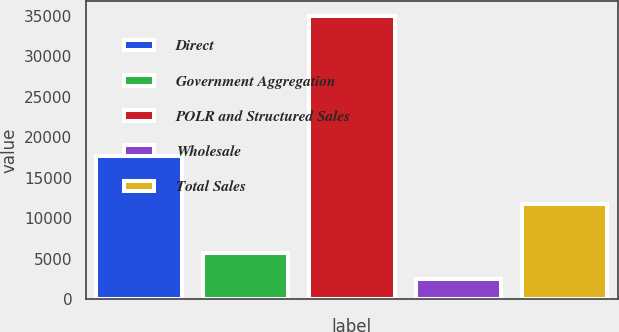Convert chart to OTSL. <chart><loc_0><loc_0><loc_500><loc_500><bar_chart><fcel>Direct<fcel>Government Aggregation<fcel>POLR and Structured Sales<fcel>Wholesale<fcel>Total Sales<nl><fcel>17688<fcel>5729.3<fcel>35018<fcel>2475<fcel>11730<nl></chart> 